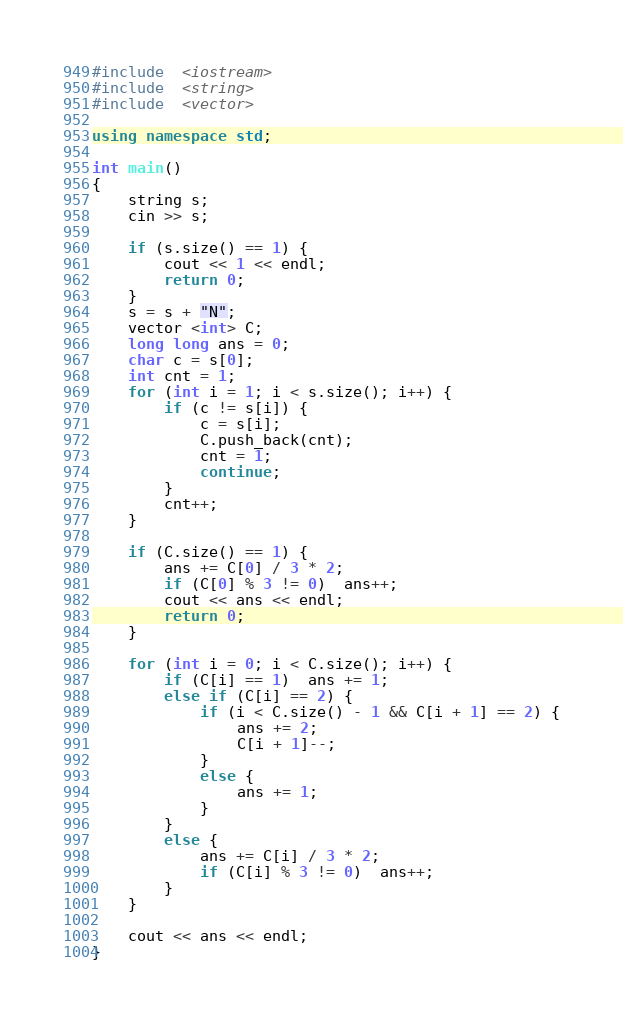<code> <loc_0><loc_0><loc_500><loc_500><_C++_>#include  <iostream>
#include  <string>
#include  <vector>

using namespace std;

int main()
{
	string s;
	cin >> s;

	if (s.size() == 1) {
		cout << 1 << endl;
		return 0;
	}
	s = s + "N";
	vector <int> C;
	long long ans = 0;
	char c = s[0];
	int cnt = 1;
	for (int i = 1; i < s.size(); i++) {
		if (c != s[i]) {
			c = s[i];
			C.push_back(cnt);
			cnt = 1;
			continue;
		}
		cnt++;
	}

	if (C.size() == 1) {
		ans += C[0] / 3 * 2;
		if (C[0] % 3 != 0)  ans++;
		cout << ans << endl;
		return 0;
	}

	for (int i = 0; i < C.size(); i++) {
		if (C[i] == 1)  ans += 1;
		else if (C[i] == 2) {
			if (i < C.size() - 1 && C[i + 1] == 2) {
				ans += 2;
				C[i + 1]--;
			}
			else {
				ans += 1;
			}
		}
		else {
			ans += C[i] / 3 * 2;
			if (C[i] % 3 != 0)  ans++;
		}
	}
	
	cout << ans << endl;
}</code> 